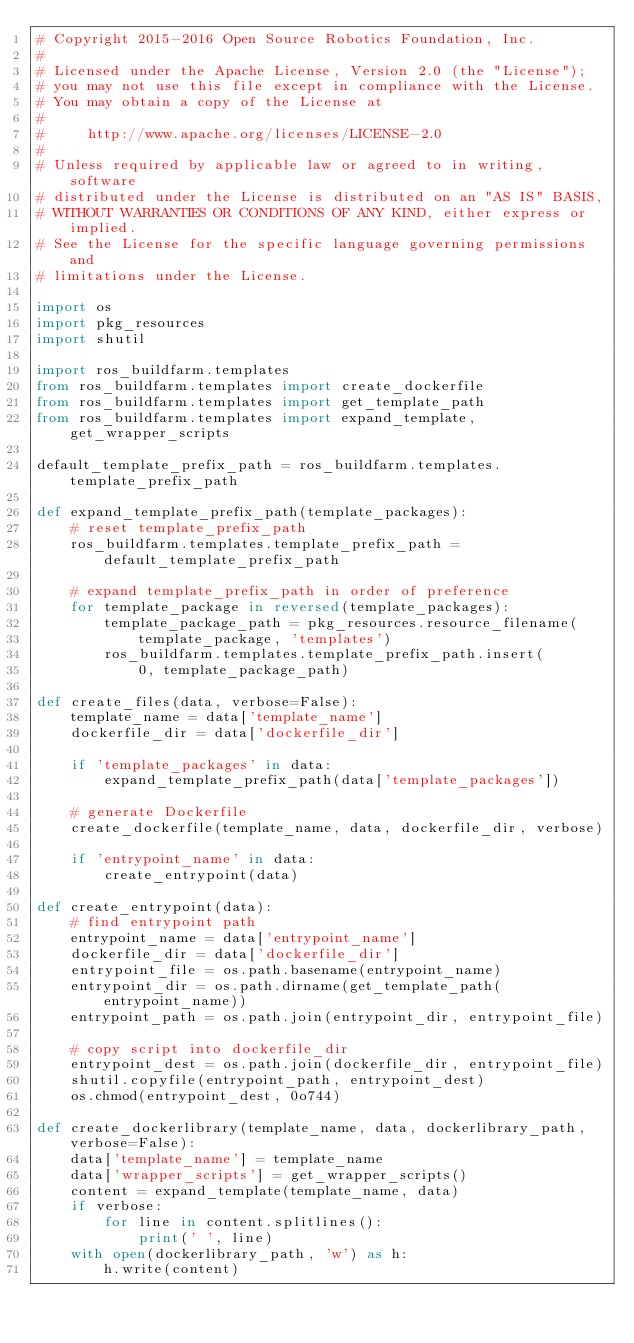Convert code to text. <code><loc_0><loc_0><loc_500><loc_500><_Python_># Copyright 2015-2016 Open Source Robotics Foundation, Inc.
#
# Licensed under the Apache License, Version 2.0 (the "License");
# you may not use this file except in compliance with the License.
# You may obtain a copy of the License at
#
#     http://www.apache.org/licenses/LICENSE-2.0
#
# Unless required by applicable law or agreed to in writing, software
# distributed under the License is distributed on an "AS IS" BASIS,
# WITHOUT WARRANTIES OR CONDITIONS OF ANY KIND, either express or implied.
# See the License for the specific language governing permissions and
# limitations under the License.

import os
import pkg_resources
import shutil

import ros_buildfarm.templates
from ros_buildfarm.templates import create_dockerfile
from ros_buildfarm.templates import get_template_path
from ros_buildfarm.templates import expand_template, get_wrapper_scripts

default_template_prefix_path = ros_buildfarm.templates.template_prefix_path

def expand_template_prefix_path(template_packages):
    # reset template_prefix_path
    ros_buildfarm.templates.template_prefix_path = default_template_prefix_path

    # expand template_prefix_path in order of preference
    for template_package in reversed(template_packages):
        template_package_path = pkg_resources.resource_filename(
            template_package, 'templates')
        ros_buildfarm.templates.template_prefix_path.insert(
            0, template_package_path)

def create_files(data, verbose=False):
    template_name = data['template_name']
    dockerfile_dir = data['dockerfile_dir']

    if 'template_packages' in data:
        expand_template_prefix_path(data['template_packages'])

    # generate Dockerfile
    create_dockerfile(template_name, data, dockerfile_dir, verbose)

    if 'entrypoint_name' in data:
        create_entrypoint(data)

def create_entrypoint(data):
    # find entrypoint path
    entrypoint_name = data['entrypoint_name']
    dockerfile_dir = data['dockerfile_dir']
    entrypoint_file = os.path.basename(entrypoint_name)
    entrypoint_dir = os.path.dirname(get_template_path(entrypoint_name))
    entrypoint_path = os.path.join(entrypoint_dir, entrypoint_file)

    # copy script into dockerfile_dir
    entrypoint_dest = os.path.join(dockerfile_dir, entrypoint_file)
    shutil.copyfile(entrypoint_path, entrypoint_dest)
    os.chmod(entrypoint_dest, 0o744)

def create_dockerlibrary(template_name, data, dockerlibrary_path, verbose=False):
    data['template_name'] = template_name
    data['wrapper_scripts'] = get_wrapper_scripts()
    content = expand_template(template_name, data)
    if verbose:
        for line in content.splitlines():
            print(' ', line)
    with open(dockerlibrary_path, 'w') as h:
        h.write(content)
</code> 